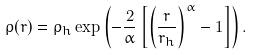Convert formula to latex. <formula><loc_0><loc_0><loc_500><loc_500>\rho ( r ) = \rho _ { h } \exp \left ( - \frac { 2 } { \alpha } \left [ \left ( \frac { r } { r _ { h } } \right ) ^ { \alpha } - 1 \right ] \right ) .</formula> 